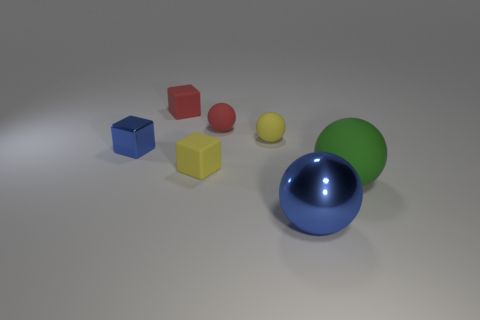What number of tiny gray metallic cubes are there?
Ensure brevity in your answer.  0. What is the material of the red block that is the same size as the blue cube?
Make the answer very short. Rubber. Is there a yellow cube of the same size as the green rubber thing?
Offer a very short reply. No. Does the rubber object that is to the left of the yellow block have the same color as the rubber cube that is in front of the tiny metallic thing?
Your answer should be compact. No. How many metallic things are gray blocks or small yellow spheres?
Provide a succinct answer. 0. How many tiny yellow matte things are right of the rubber cube in front of the blue thing behind the big blue shiny thing?
Provide a succinct answer. 1. What is the size of the yellow cube that is made of the same material as the green thing?
Your response must be concise. Small. How many big things are the same color as the small metal thing?
Provide a short and direct response. 1. Does the yellow rubber object to the left of the red matte sphere have the same size as the green rubber object?
Your answer should be very brief. No. There is a ball that is in front of the tiny metallic object and behind the big blue shiny object; what color is it?
Provide a succinct answer. Green. 